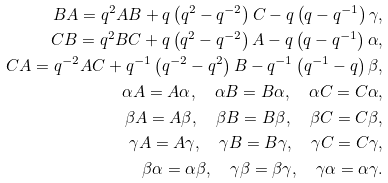<formula> <loc_0><loc_0><loc_500><loc_500>B A = q ^ { 2 } A B + q \left ( q ^ { 2 } - q ^ { - 2 } \right ) C - q \left ( q - q ^ { - 1 } \right ) \gamma , \\ C B = q ^ { 2 } B C + q \left ( q ^ { 2 } - q ^ { - 2 } \right ) A - q \left ( q - q ^ { - 1 } \right ) \alpha , \\ C A = q ^ { - 2 } A C + q ^ { - 1 } \left ( q ^ { - 2 } - q ^ { 2 } \right ) B - q ^ { - 1 } \left ( q ^ { - 1 } - q \right ) \beta , \\ \alpha A = A \alpha , \quad \alpha B = B \alpha , \quad \alpha C = C \alpha , \\ \beta A = A \beta , \quad \beta B = B \beta , \quad \beta C = C \beta , \\ \gamma A = A \gamma , \quad \gamma B = B \gamma , \quad \gamma C = C \gamma , \\ \beta \alpha = \alpha \beta , \quad \gamma \beta = \beta \gamma , \quad \gamma \alpha = \alpha \gamma .</formula> 